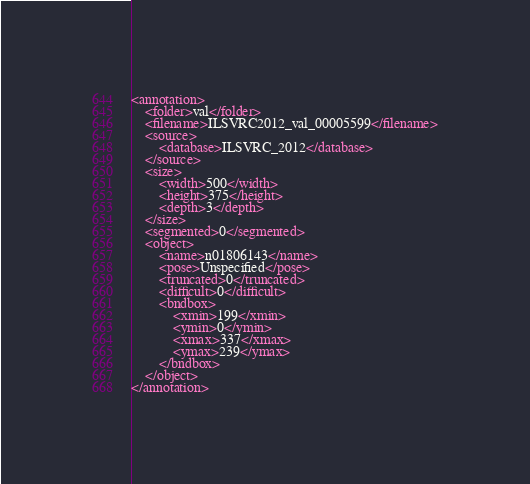Convert code to text. <code><loc_0><loc_0><loc_500><loc_500><_XML_><annotation>
	<folder>val</folder>
	<filename>ILSVRC2012_val_00005599</filename>
	<source>
		<database>ILSVRC_2012</database>
	</source>
	<size>
		<width>500</width>
		<height>375</height>
		<depth>3</depth>
	</size>
	<segmented>0</segmented>
	<object>
		<name>n01806143</name>
		<pose>Unspecified</pose>
		<truncated>0</truncated>
		<difficult>0</difficult>
		<bndbox>
			<xmin>199</xmin>
			<ymin>0</ymin>
			<xmax>337</xmax>
			<ymax>239</ymax>
		</bndbox>
	</object>
</annotation></code> 